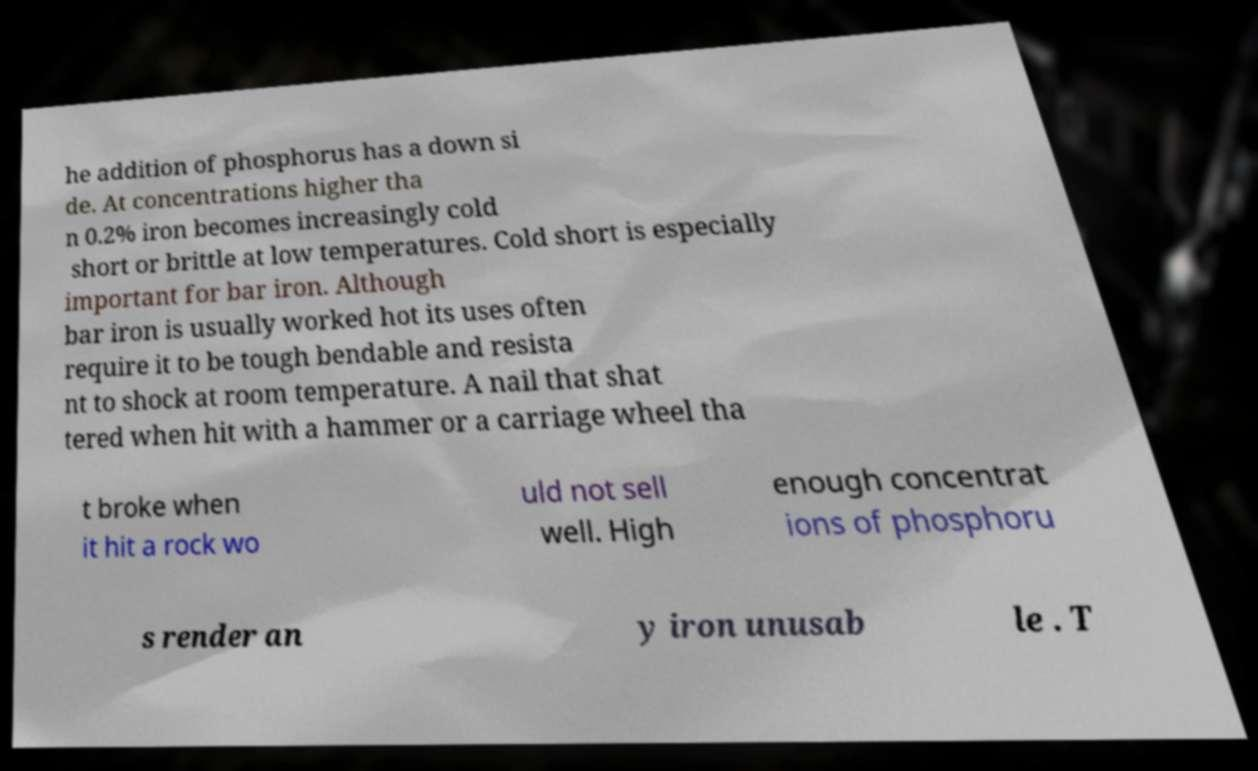There's text embedded in this image that I need extracted. Can you transcribe it verbatim? he addition of phosphorus has a down si de. At concentrations higher tha n 0.2% iron becomes increasingly cold short or brittle at low temperatures. Cold short is especially important for bar iron. Although bar iron is usually worked hot its uses often require it to be tough bendable and resista nt to shock at room temperature. A nail that shat tered when hit with a hammer or a carriage wheel tha t broke when it hit a rock wo uld not sell well. High enough concentrat ions of phosphoru s render an y iron unusab le . T 